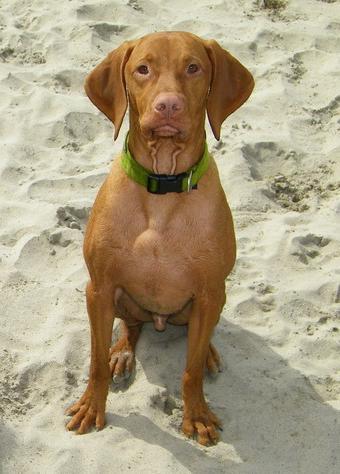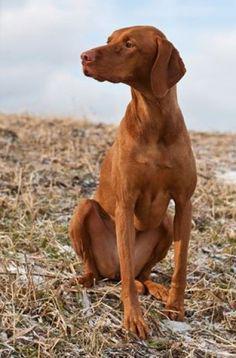The first image is the image on the left, the second image is the image on the right. Given the left and right images, does the statement "One dog is standing." hold true? Answer yes or no. No. 